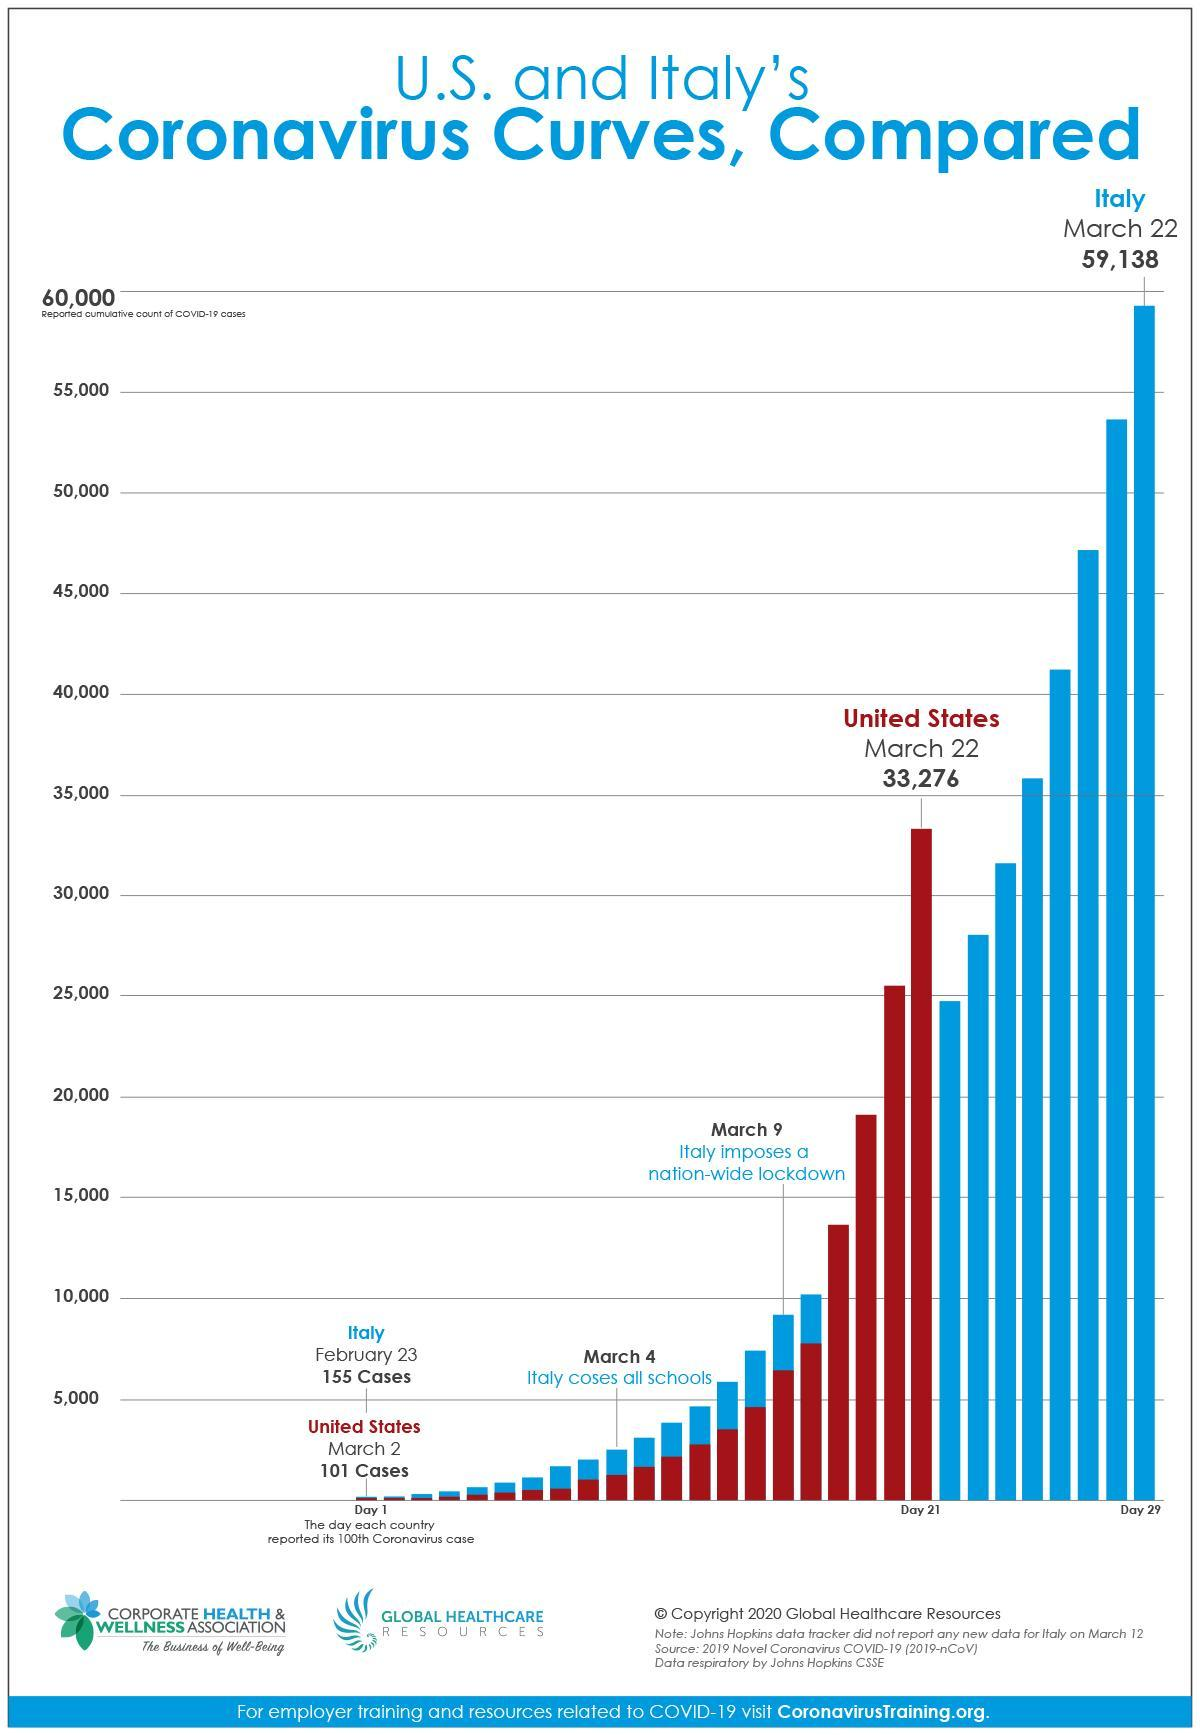What was the number of cases in Italy on March 22?
Answer the question with a short phrase. 59,138 What was the number of cases in US on March 22? 33,276 When did Italy cross 100 cases? February 23 On which day did the number of cases cross 100 in US? March 2 When did schools close in Italy? March 4 